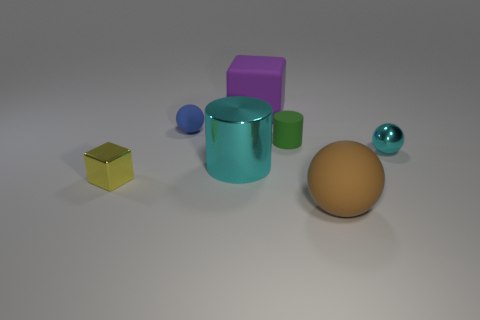Add 1 tiny yellow metallic cubes. How many objects exist? 8 Subtract all cubes. How many objects are left? 5 Add 4 matte objects. How many matte objects exist? 8 Subtract 0 gray spheres. How many objects are left? 7 Subtract all small metallic objects. Subtract all small matte things. How many objects are left? 3 Add 5 tiny shiny blocks. How many tiny shiny blocks are left? 6 